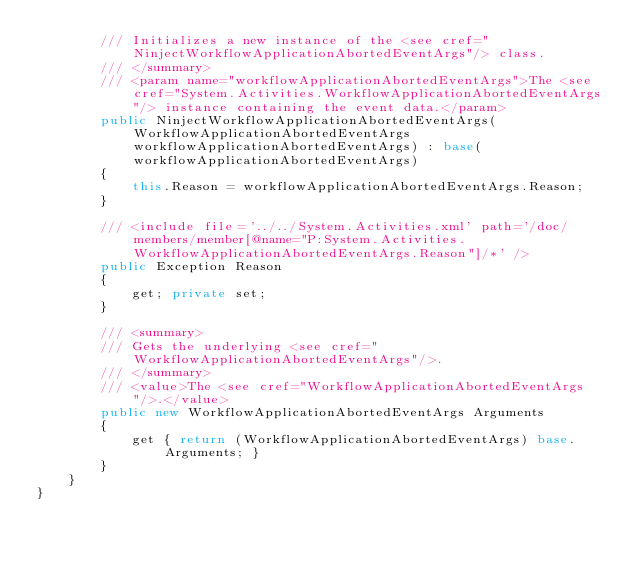<code> <loc_0><loc_0><loc_500><loc_500><_C#_>        /// Initializes a new instance of the <see cref="NinjectWorkflowApplicationAbortedEventArgs"/> class.
        /// </summary>
        /// <param name="workflowApplicationAbortedEventArgs">The <see cref="System.Activities.WorkflowApplicationAbortedEventArgs"/> instance containing the event data.</param>
        public NinjectWorkflowApplicationAbortedEventArgs(WorkflowApplicationAbortedEventArgs workflowApplicationAbortedEventArgs) : base(workflowApplicationAbortedEventArgs)
        {
            this.Reason = workflowApplicationAbortedEventArgs.Reason;
        }

        /// <include file='../../System.Activities.xml' path='/doc/members/member[@name="P:System.Activities.WorkflowApplicationAbortedEventArgs.Reason"]/*' />
        public Exception Reason
        {
            get; private set;
        }

        /// <summary>
        /// Gets the underlying <see cref="WorkflowApplicationAbortedEventArgs"/>.
        /// </summary>
        /// <value>The <see cref="WorkflowApplicationAbortedEventArgs"/>.</value>
        public new WorkflowApplicationAbortedEventArgs Arguments
        {
            get { return (WorkflowApplicationAbortedEventArgs) base.Arguments; }
        }
    }
}</code> 